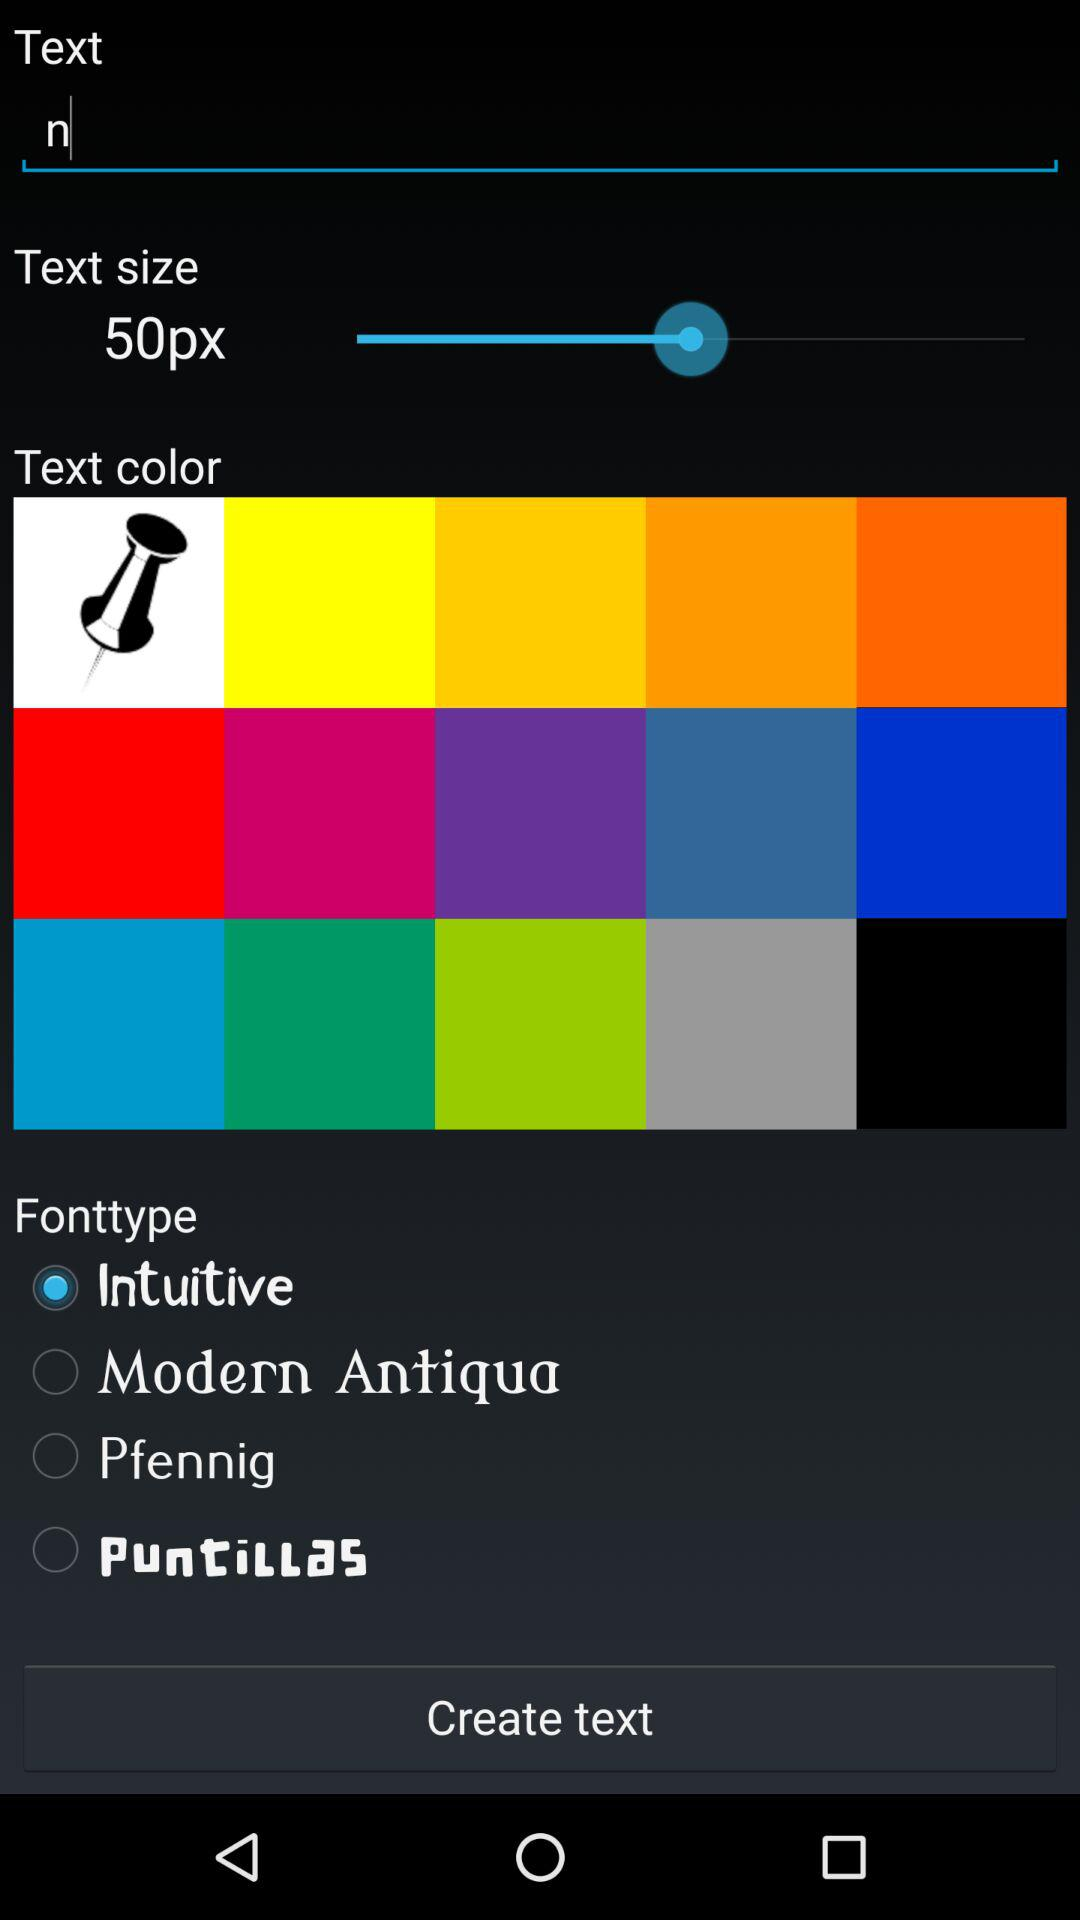What is the text size? The text size is 50px. 